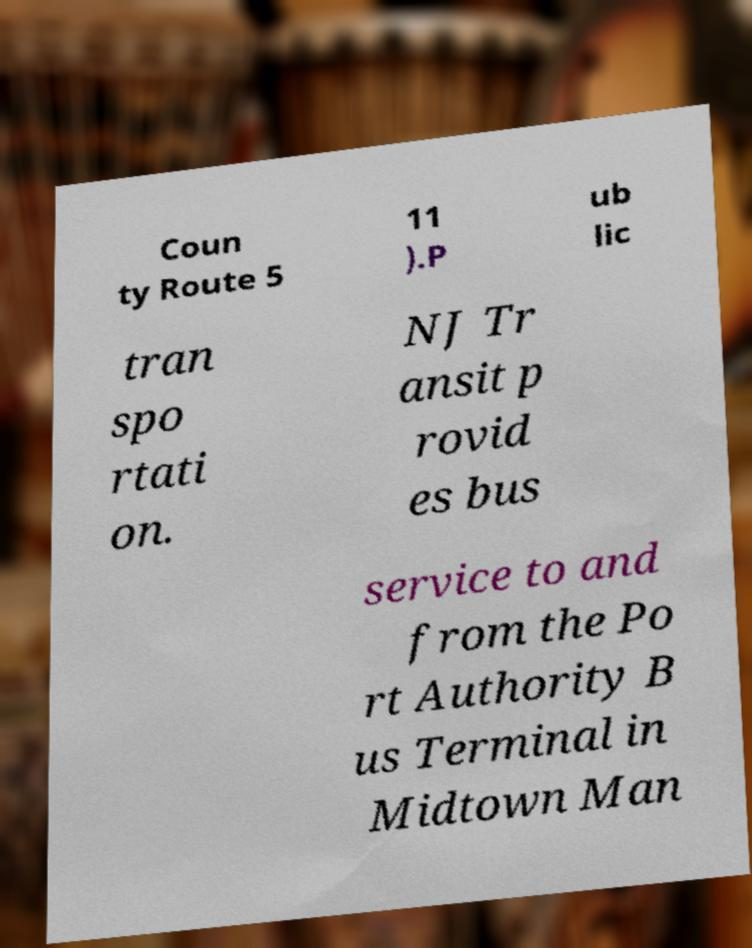For documentation purposes, I need the text within this image transcribed. Could you provide that? Coun ty Route 5 11 ).P ub lic tran spo rtati on. NJ Tr ansit p rovid es bus service to and from the Po rt Authority B us Terminal in Midtown Man 